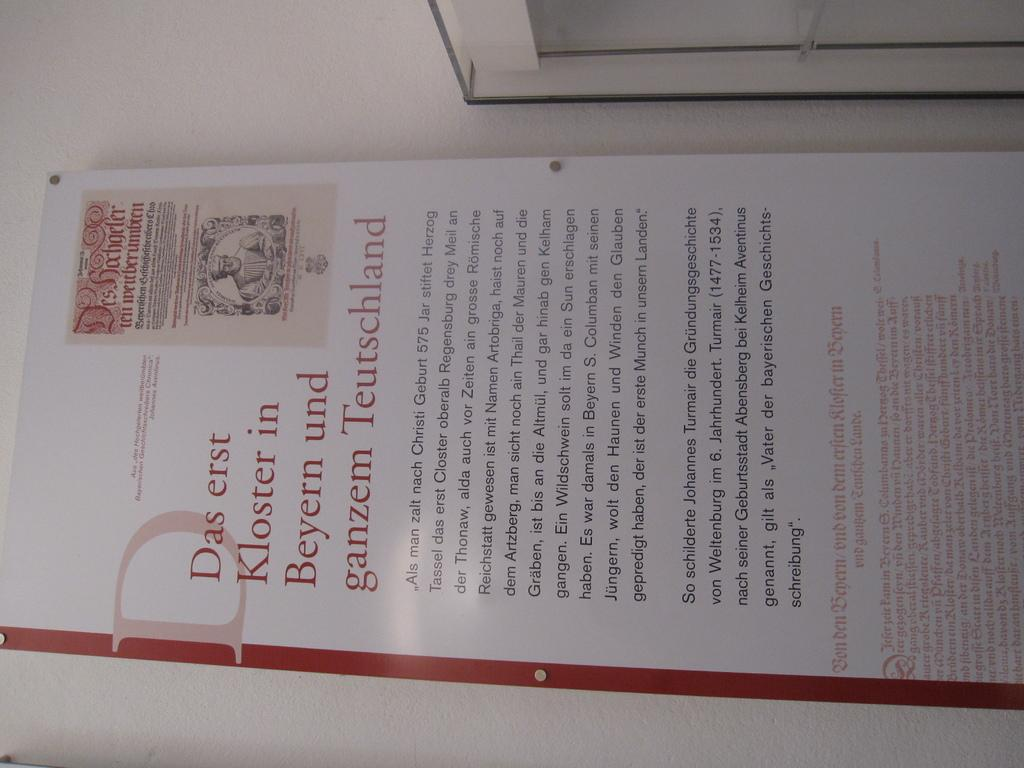<image>
Present a compact description of the photo's key features. A sign starts with the words "Das erst Kloster in" and has some text in red. 